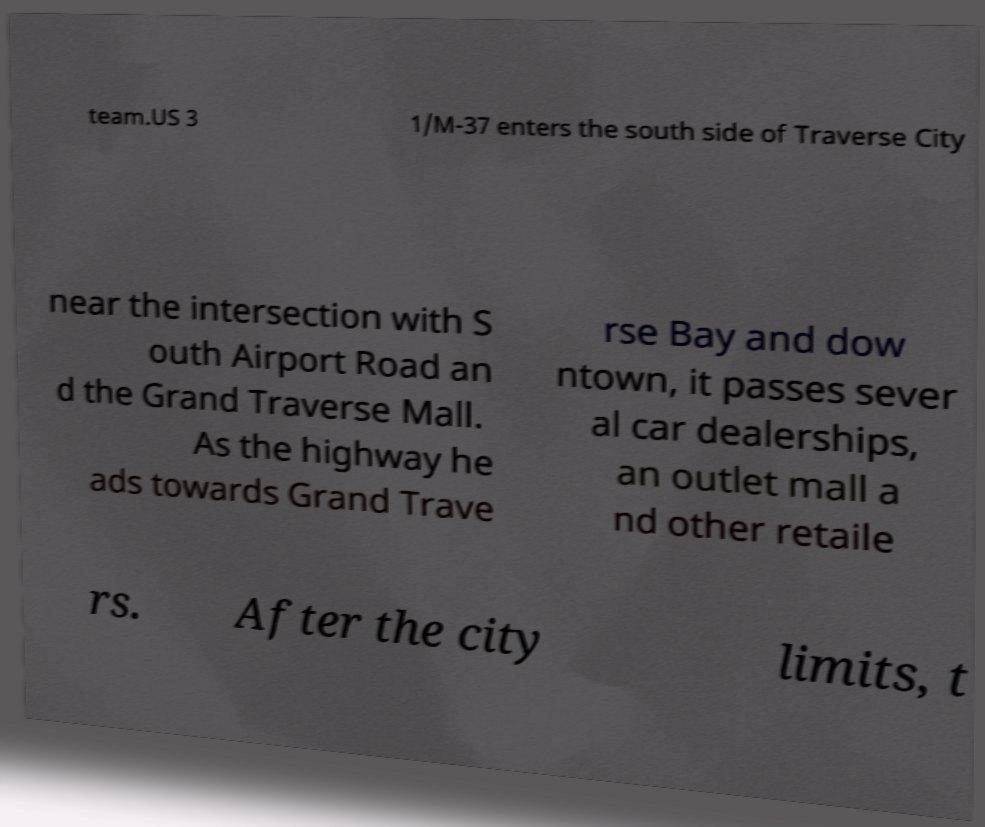Can you read and provide the text displayed in the image?This photo seems to have some interesting text. Can you extract and type it out for me? team.US 3 1/M-37 enters the south side of Traverse City near the intersection with S outh Airport Road an d the Grand Traverse Mall. As the highway he ads towards Grand Trave rse Bay and dow ntown, it passes sever al car dealerships, an outlet mall a nd other retaile rs. After the city limits, t 